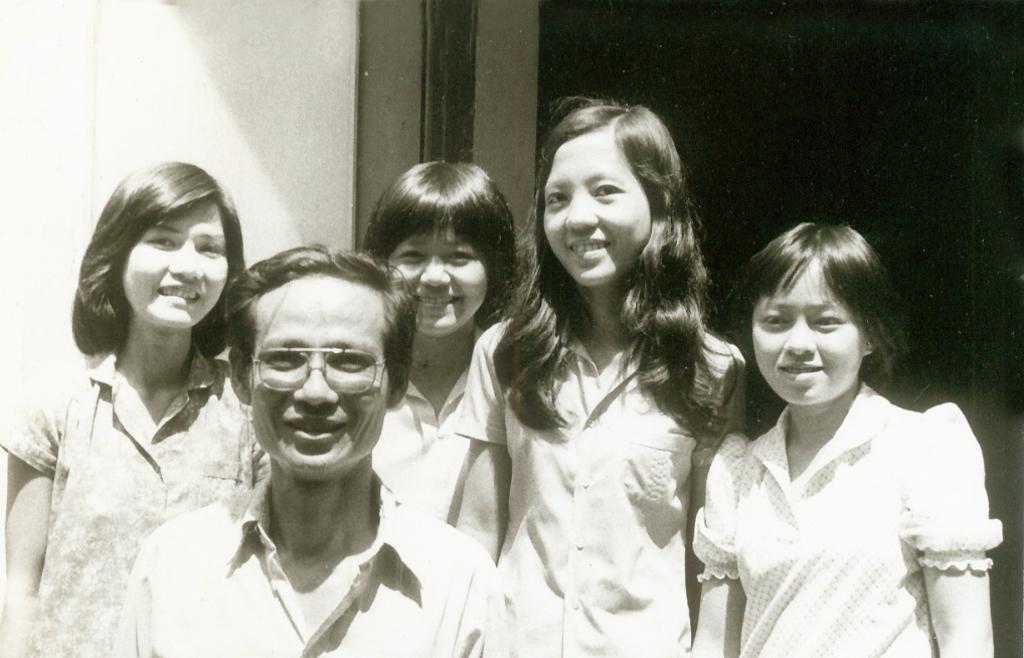Describe this image in one or two sentences. This is a black and white image. I can see a group of people standing and smiling. In the background, there is a wall. 